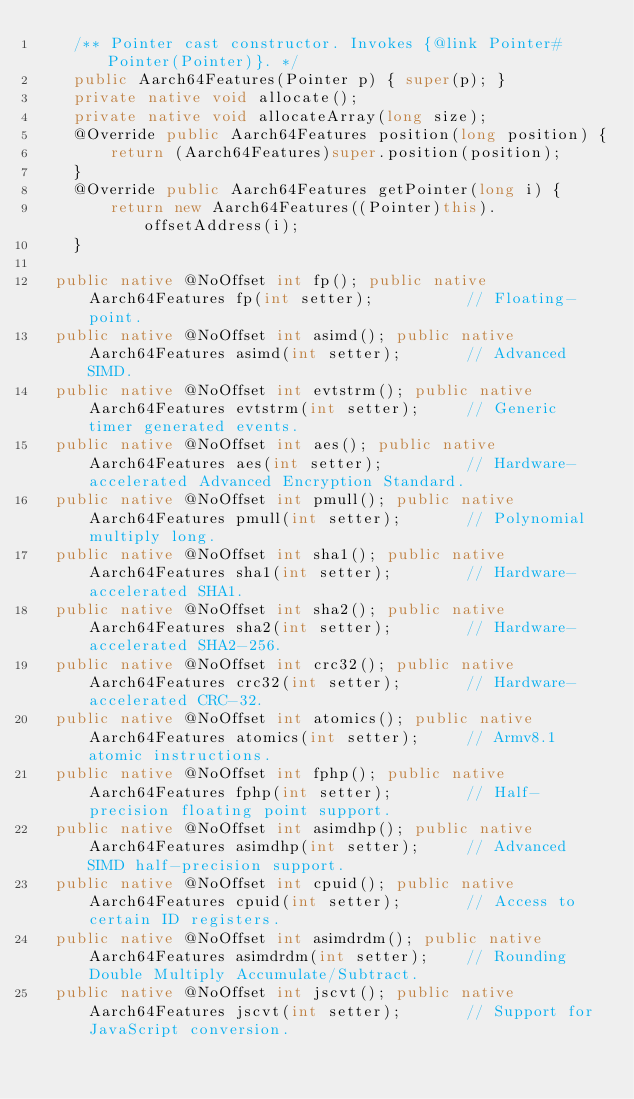<code> <loc_0><loc_0><loc_500><loc_500><_Java_>    /** Pointer cast constructor. Invokes {@link Pointer#Pointer(Pointer)}. */
    public Aarch64Features(Pointer p) { super(p); }
    private native void allocate();
    private native void allocateArray(long size);
    @Override public Aarch64Features position(long position) {
        return (Aarch64Features)super.position(position);
    }
    @Override public Aarch64Features getPointer(long i) {
        return new Aarch64Features((Pointer)this).offsetAddress(i);
    }

  public native @NoOffset int fp(); public native Aarch64Features fp(int setter);          // Floating-point.
  public native @NoOffset int asimd(); public native Aarch64Features asimd(int setter);       // Advanced SIMD.
  public native @NoOffset int evtstrm(); public native Aarch64Features evtstrm(int setter);     // Generic timer generated events.
  public native @NoOffset int aes(); public native Aarch64Features aes(int setter);         // Hardware-accelerated Advanced Encryption Standard.
  public native @NoOffset int pmull(); public native Aarch64Features pmull(int setter);       // Polynomial multiply long.
  public native @NoOffset int sha1(); public native Aarch64Features sha1(int setter);        // Hardware-accelerated SHA1.
  public native @NoOffset int sha2(); public native Aarch64Features sha2(int setter);        // Hardware-accelerated SHA2-256.
  public native @NoOffset int crc32(); public native Aarch64Features crc32(int setter);       // Hardware-accelerated CRC-32.
  public native @NoOffset int atomics(); public native Aarch64Features atomics(int setter);     // Armv8.1 atomic instructions.
  public native @NoOffset int fphp(); public native Aarch64Features fphp(int setter);        // Half-precision floating point support.
  public native @NoOffset int asimdhp(); public native Aarch64Features asimdhp(int setter);     // Advanced SIMD half-precision support.
  public native @NoOffset int cpuid(); public native Aarch64Features cpuid(int setter);       // Access to certain ID registers.
  public native @NoOffset int asimdrdm(); public native Aarch64Features asimdrdm(int setter);    // Rounding Double Multiply Accumulate/Subtract.
  public native @NoOffset int jscvt(); public native Aarch64Features jscvt(int setter);       // Support for JavaScript conversion.</code> 